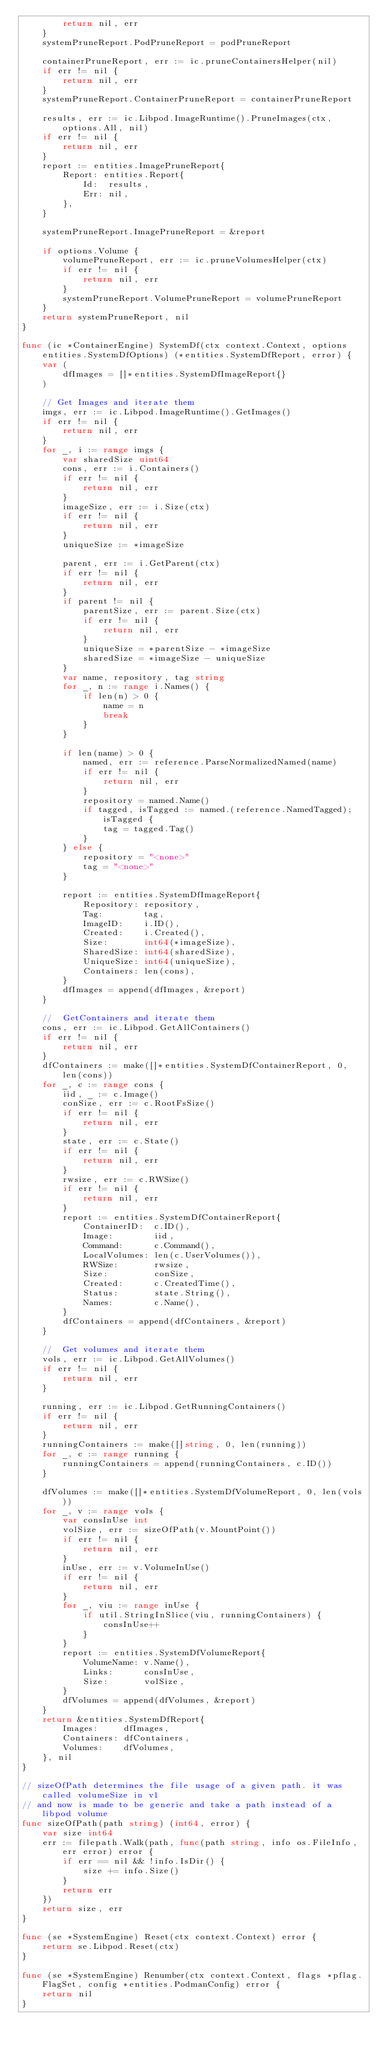Convert code to text. <code><loc_0><loc_0><loc_500><loc_500><_Go_>		return nil, err
	}
	systemPruneReport.PodPruneReport = podPruneReport

	containerPruneReport, err := ic.pruneContainersHelper(nil)
	if err != nil {
		return nil, err
	}
	systemPruneReport.ContainerPruneReport = containerPruneReport

	results, err := ic.Libpod.ImageRuntime().PruneImages(ctx, options.All, nil)
	if err != nil {
		return nil, err
	}
	report := entities.ImagePruneReport{
		Report: entities.Report{
			Id:  results,
			Err: nil,
		},
	}

	systemPruneReport.ImagePruneReport = &report

	if options.Volume {
		volumePruneReport, err := ic.pruneVolumesHelper(ctx)
		if err != nil {
			return nil, err
		}
		systemPruneReport.VolumePruneReport = volumePruneReport
	}
	return systemPruneReport, nil
}

func (ic *ContainerEngine) SystemDf(ctx context.Context, options entities.SystemDfOptions) (*entities.SystemDfReport, error) {
	var (
		dfImages = []*entities.SystemDfImageReport{}
	)

	// Get Images and iterate them
	imgs, err := ic.Libpod.ImageRuntime().GetImages()
	if err != nil {
		return nil, err
	}
	for _, i := range imgs {
		var sharedSize uint64
		cons, err := i.Containers()
		if err != nil {
			return nil, err
		}
		imageSize, err := i.Size(ctx)
		if err != nil {
			return nil, err
		}
		uniqueSize := *imageSize

		parent, err := i.GetParent(ctx)
		if err != nil {
			return nil, err
		}
		if parent != nil {
			parentSize, err := parent.Size(ctx)
			if err != nil {
				return nil, err
			}
			uniqueSize = *parentSize - *imageSize
			sharedSize = *imageSize - uniqueSize
		}
		var name, repository, tag string
		for _, n := range i.Names() {
			if len(n) > 0 {
				name = n
				break
			}
		}

		if len(name) > 0 {
			named, err := reference.ParseNormalizedNamed(name)
			if err != nil {
				return nil, err
			}
			repository = named.Name()
			if tagged, isTagged := named.(reference.NamedTagged); isTagged {
				tag = tagged.Tag()
			}
		} else {
			repository = "<none>"
			tag = "<none>"
		}

		report := entities.SystemDfImageReport{
			Repository: repository,
			Tag:        tag,
			ImageID:    i.ID(),
			Created:    i.Created(),
			Size:       int64(*imageSize),
			SharedSize: int64(sharedSize),
			UniqueSize: int64(uniqueSize),
			Containers: len(cons),
		}
		dfImages = append(dfImages, &report)
	}

	//	GetContainers and iterate them
	cons, err := ic.Libpod.GetAllContainers()
	if err != nil {
		return nil, err
	}
	dfContainers := make([]*entities.SystemDfContainerReport, 0, len(cons))
	for _, c := range cons {
		iid, _ := c.Image()
		conSize, err := c.RootFsSize()
		if err != nil {
			return nil, err
		}
		state, err := c.State()
		if err != nil {
			return nil, err
		}
		rwsize, err := c.RWSize()
		if err != nil {
			return nil, err
		}
		report := entities.SystemDfContainerReport{
			ContainerID:  c.ID(),
			Image:        iid,
			Command:      c.Command(),
			LocalVolumes: len(c.UserVolumes()),
			RWSize:       rwsize,
			Size:         conSize,
			Created:      c.CreatedTime(),
			Status:       state.String(),
			Names:        c.Name(),
		}
		dfContainers = append(dfContainers, &report)
	}

	//	Get volumes and iterate them
	vols, err := ic.Libpod.GetAllVolumes()
	if err != nil {
		return nil, err
	}

	running, err := ic.Libpod.GetRunningContainers()
	if err != nil {
		return nil, err
	}
	runningContainers := make([]string, 0, len(running))
	for _, c := range running {
		runningContainers = append(runningContainers, c.ID())
	}

	dfVolumes := make([]*entities.SystemDfVolumeReport, 0, len(vols))
	for _, v := range vols {
		var consInUse int
		volSize, err := sizeOfPath(v.MountPoint())
		if err != nil {
			return nil, err
		}
		inUse, err := v.VolumeInUse()
		if err != nil {
			return nil, err
		}
		for _, viu := range inUse {
			if util.StringInSlice(viu, runningContainers) {
				consInUse++
			}
		}
		report := entities.SystemDfVolumeReport{
			VolumeName: v.Name(),
			Links:      consInUse,
			Size:       volSize,
		}
		dfVolumes = append(dfVolumes, &report)
	}
	return &entities.SystemDfReport{
		Images:     dfImages,
		Containers: dfContainers,
		Volumes:    dfVolumes,
	}, nil
}

// sizeOfPath determines the file usage of a given path. it was called volumeSize in v1
// and now is made to be generic and take a path instead of a libpod volume
func sizeOfPath(path string) (int64, error) {
	var size int64
	err := filepath.Walk(path, func(path string, info os.FileInfo, err error) error {
		if err == nil && !info.IsDir() {
			size += info.Size()
		}
		return err
	})
	return size, err
}

func (se *SystemEngine) Reset(ctx context.Context) error {
	return se.Libpod.Reset(ctx)
}

func (se *SystemEngine) Renumber(ctx context.Context, flags *pflag.FlagSet, config *entities.PodmanConfig) error {
	return nil
}
</code> 